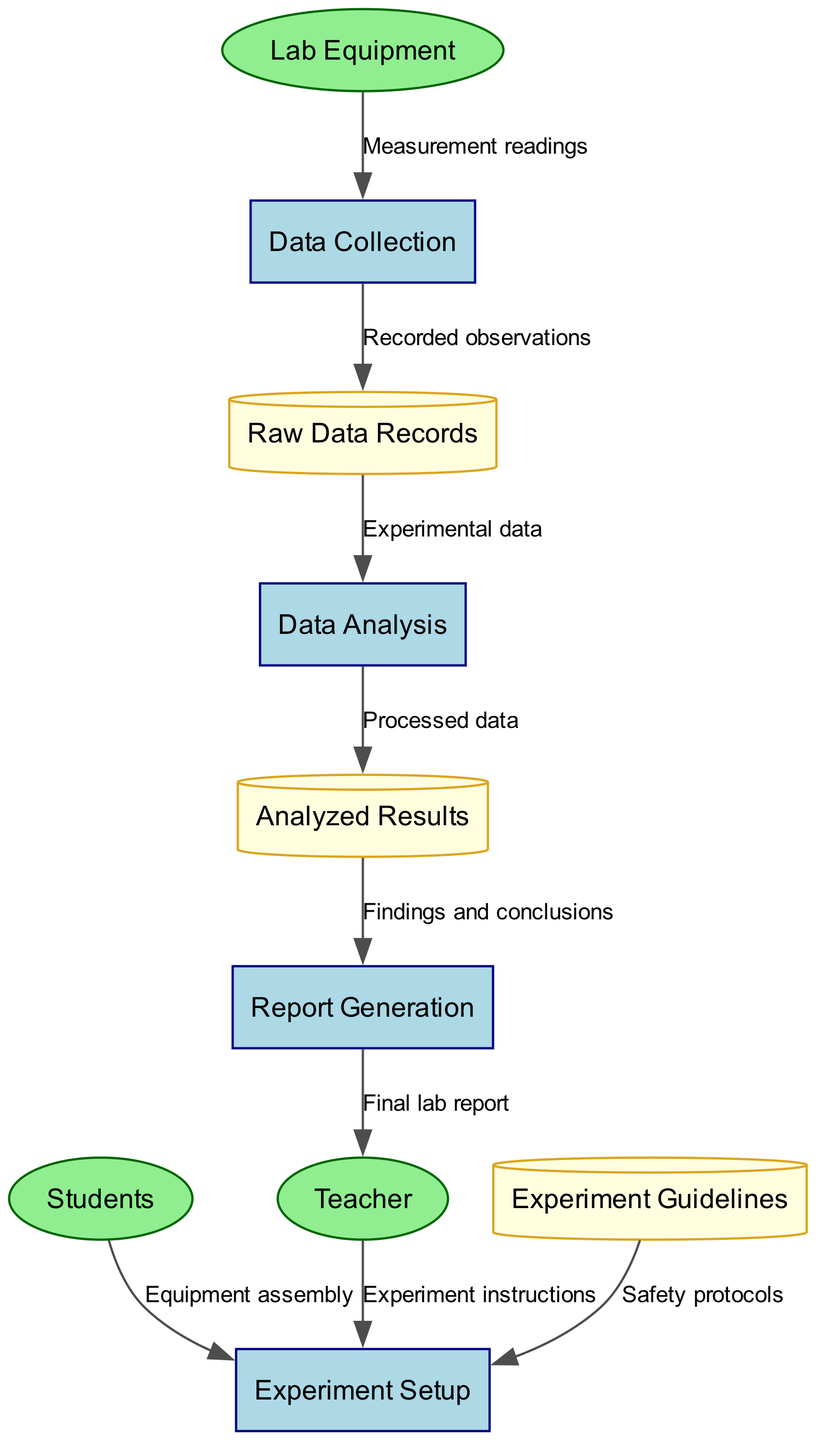What are the four main processes in the diagram? The diagram outlines four main processes: Experiment Setup, Data Collection, Data Analysis, and Report Generation. This is derived from the section listing the processes directly in the diagram.
Answer: Experiment Setup, Data Collection, Data Analysis, Report Generation Which external entity provides the experiment instructions? The Teacher is the external entity that provides the experiment instructions, as indicated by the directed flow from the Teacher to the Experiment Setup process.
Answer: Teacher How many data stores are shown in the diagram? There are three data stores depicted: Experiment Guidelines, Raw Data Records, and Analyzed Results. This count is obtained by listing each unique data store shown in the diagram.
Answer: 3 What type of data is transferred from Raw Data Records to Data Analysis? The data labeled as "Experimental data" is transferred from Raw Data Records to Data Analysis, as indicated in the data flow description between these two nodes in the diagram.
Answer: Experimental data What is the final output generated by the Report Generation process? The final output produced by the Report Generation process is the "Final lab report," as indicated by the directed flow leading to the Teacher that is labeled accordingly.
Answer: Final lab report Which process receives measurement readings from the Lab Equipment? The Data Collection process receives the measurement readings from the Lab Equipment, based on the directed flow connecting these two nodes within the diagram.
Answer: Data Collection What is the relationship between Analyzed Results and Report Generation? The Analyzed Results process provides "Findings and conclusions" to the Report Generation process; this is shown in the flow from Analyzed Results to Report Generation.
Answer: Findings and conclusions How do Students interact with the Experiment Setup process? Students interact with the Experiment Setup process by sending "Equipment assembly," which is shown as an outbound flow leading to the Experiment Setup node.
Answer: Equipment assembly 